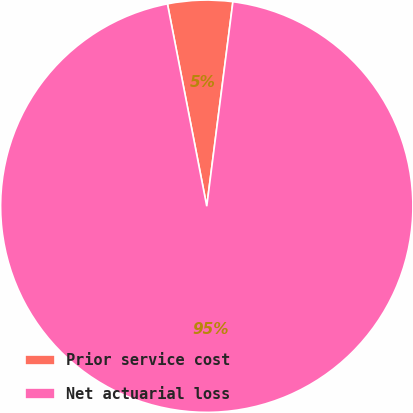<chart> <loc_0><loc_0><loc_500><loc_500><pie_chart><fcel>Prior service cost<fcel>Net actuarial loss<nl><fcel>5.08%<fcel>94.92%<nl></chart> 